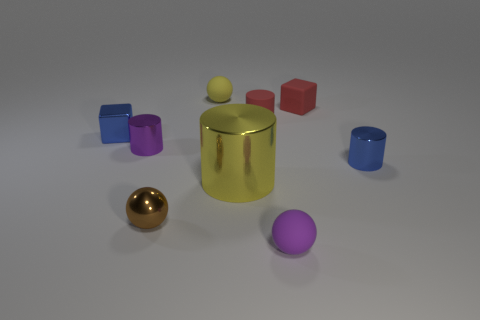Subtract all tiny red matte cylinders. How many cylinders are left? 3 Add 1 large yellow metallic cylinders. How many objects exist? 10 Subtract all blue cubes. How many cubes are left? 1 Subtract 3 cylinders. How many cylinders are left? 1 Subtract all cylinders. How many objects are left? 5 Subtract all yellow cylinders. Subtract all small purple shiny things. How many objects are left? 7 Add 6 small cubes. How many small cubes are left? 8 Add 7 brown balls. How many brown balls exist? 8 Subtract 1 blue cubes. How many objects are left? 8 Subtract all yellow cubes. Subtract all purple cylinders. How many cubes are left? 2 